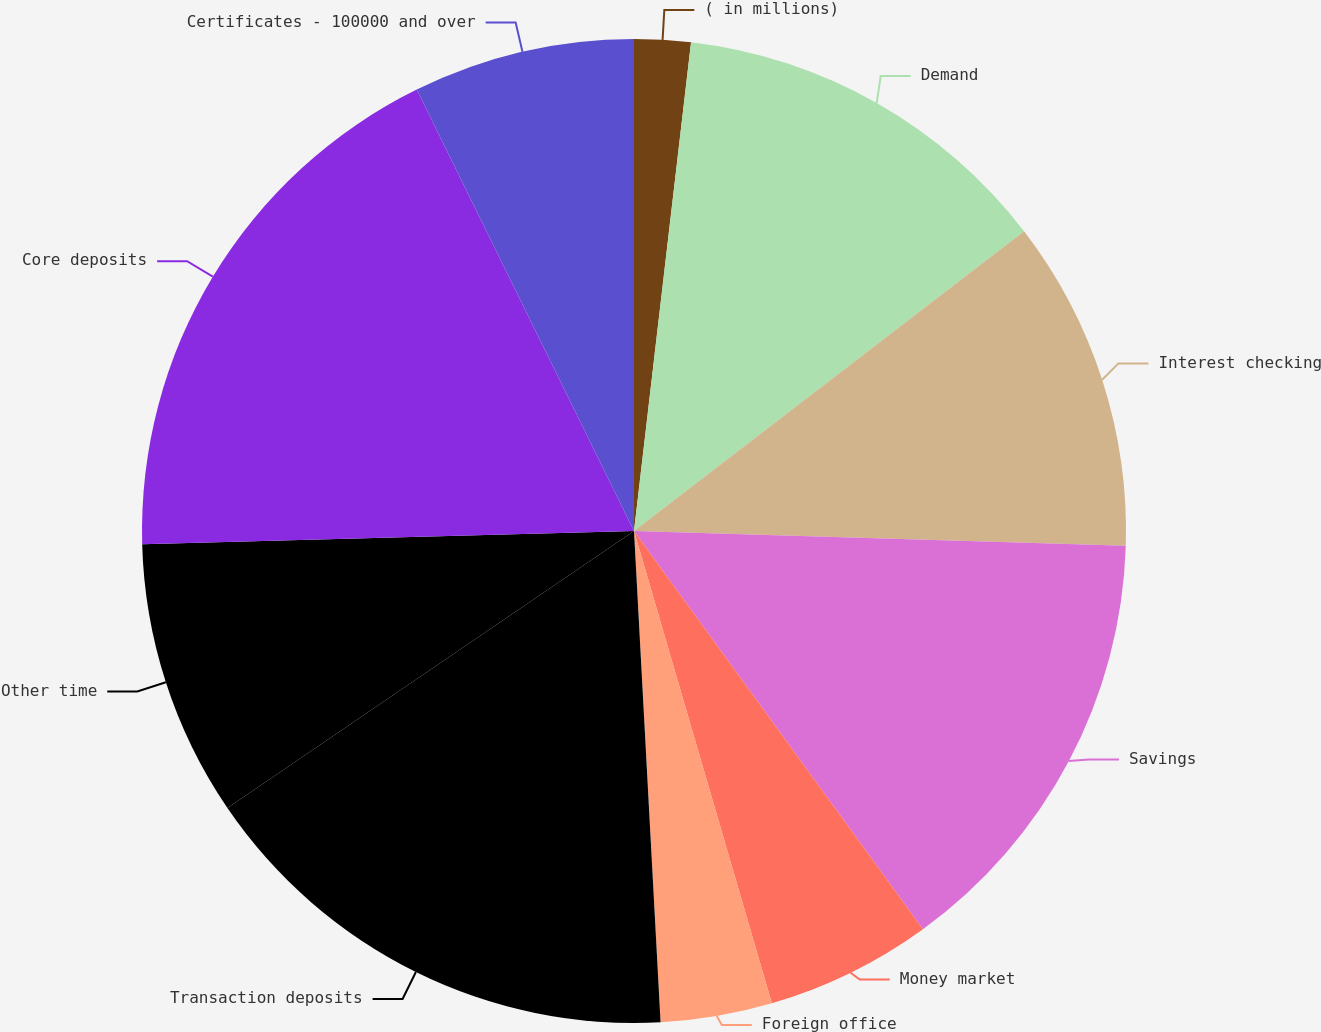Convert chart. <chart><loc_0><loc_0><loc_500><loc_500><pie_chart><fcel>( in millions)<fcel>Demand<fcel>Interest checking<fcel>Savings<fcel>Money market<fcel>Foreign office<fcel>Transaction deposits<fcel>Other time<fcel>Core deposits<fcel>Certificates - 100000 and over<nl><fcel>1.85%<fcel>12.72%<fcel>10.91%<fcel>14.53%<fcel>5.47%<fcel>3.66%<fcel>16.34%<fcel>9.09%<fcel>18.15%<fcel>7.28%<nl></chart> 